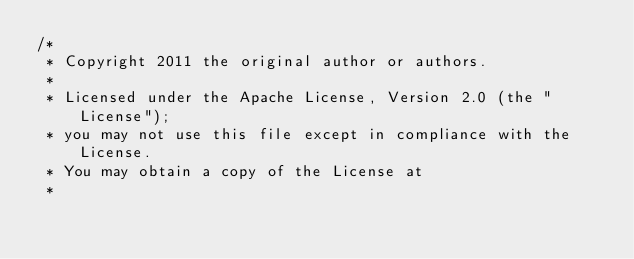Convert code to text. <code><loc_0><loc_0><loc_500><loc_500><_Java_>/*
 * Copyright 2011 the original author or authors.
 *
 * Licensed under the Apache License, Version 2.0 (the "License");
 * you may not use this file except in compliance with the License.
 * You may obtain a copy of the License at
 *</code> 